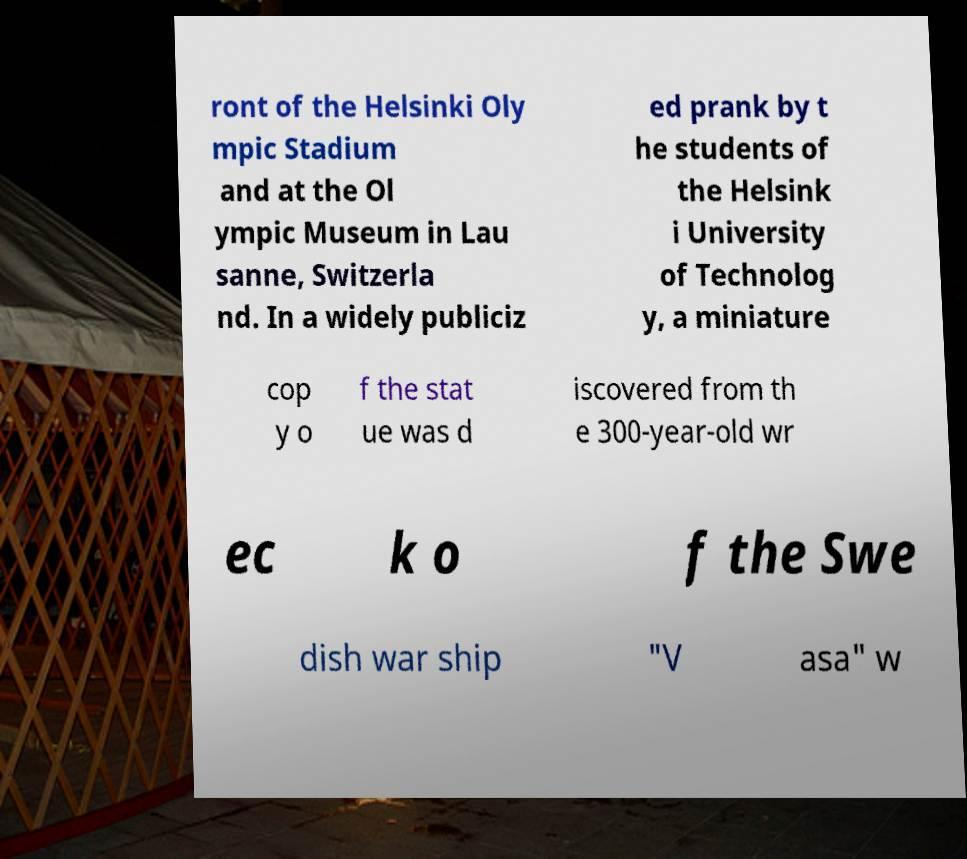Please identify and transcribe the text found in this image. ront of the Helsinki Oly mpic Stadium and at the Ol ympic Museum in Lau sanne, Switzerla nd. In a widely publiciz ed prank by t he students of the Helsink i University of Technolog y, a miniature cop y o f the stat ue was d iscovered from th e 300-year-old wr ec k o f the Swe dish war ship "V asa" w 